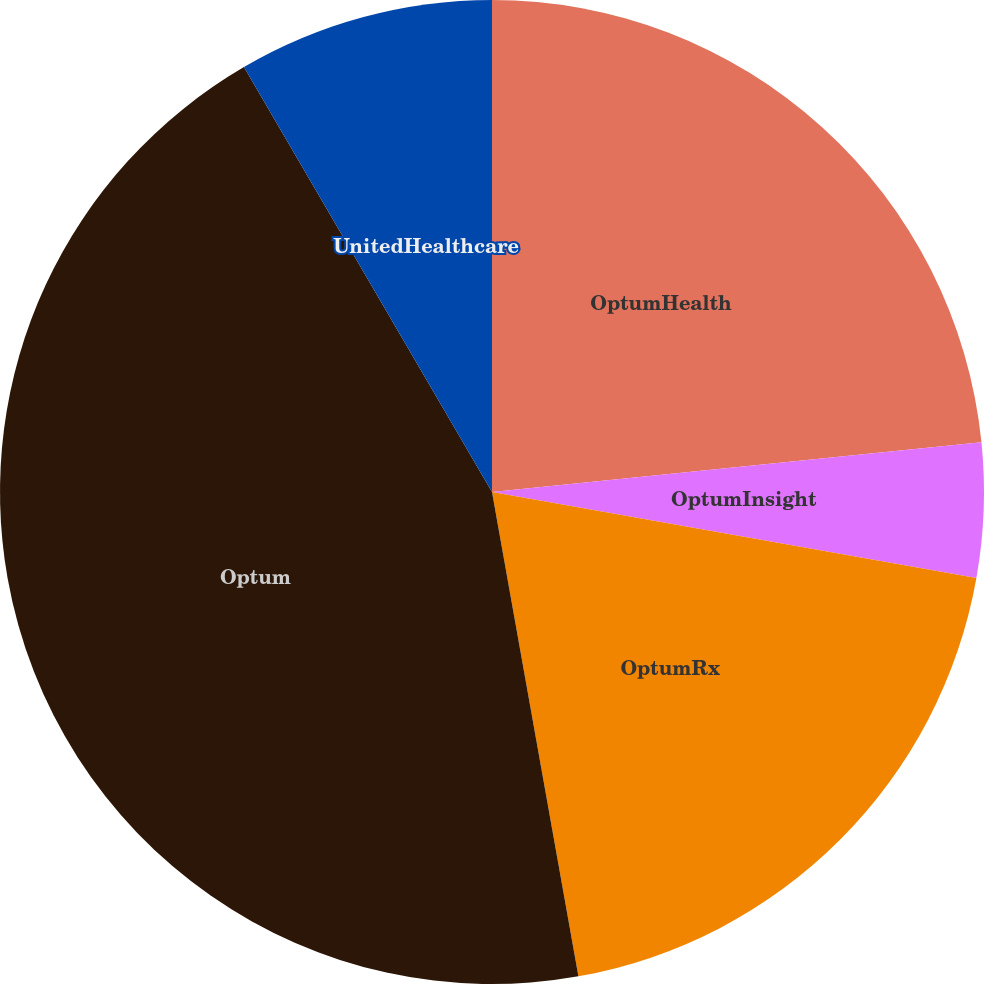Convert chart. <chart><loc_0><loc_0><loc_500><loc_500><pie_chart><fcel>OptumHealth<fcel>OptumInsight<fcel>OptumRx<fcel>Optum<fcel>UnitedHealthcare<nl><fcel>23.39%<fcel>4.41%<fcel>19.39%<fcel>44.4%<fcel>8.41%<nl></chart> 